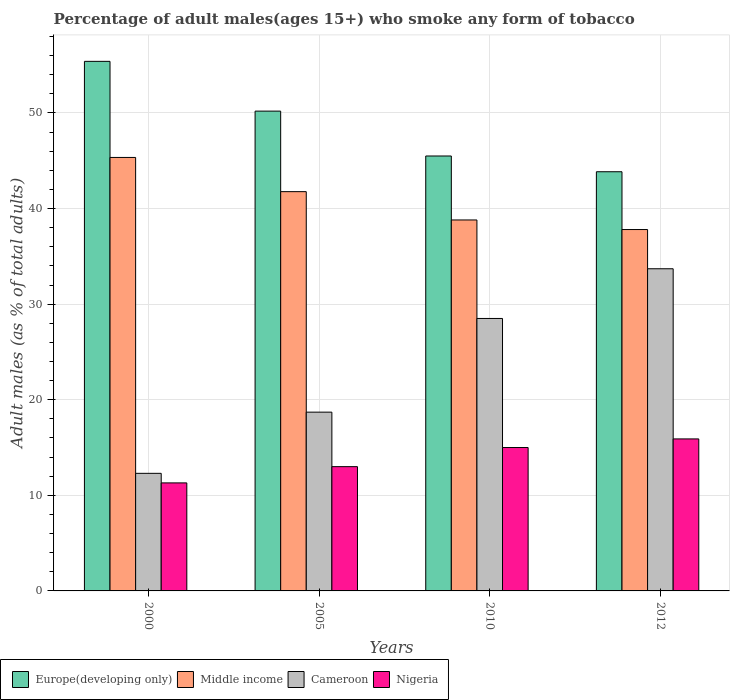How many different coloured bars are there?
Your answer should be compact. 4. What is the percentage of adult males who smoke in Europe(developing only) in 2005?
Provide a succinct answer. 50.19. Across all years, what is the maximum percentage of adult males who smoke in Cameroon?
Provide a succinct answer. 33.7. Across all years, what is the minimum percentage of adult males who smoke in Europe(developing only)?
Offer a terse response. 43.85. In which year was the percentage of adult males who smoke in Middle income minimum?
Your response must be concise. 2012. What is the total percentage of adult males who smoke in Europe(developing only) in the graph?
Your response must be concise. 194.93. What is the difference between the percentage of adult males who smoke in Middle income in 2005 and that in 2012?
Make the answer very short. 3.96. What is the difference between the percentage of adult males who smoke in Europe(developing only) in 2000 and the percentage of adult males who smoke in Cameroon in 2010?
Your answer should be compact. 26.9. What is the average percentage of adult males who smoke in Middle income per year?
Keep it short and to the point. 40.93. In how many years, is the percentage of adult males who smoke in Cameroon greater than 24 %?
Offer a very short reply. 2. What is the ratio of the percentage of adult males who smoke in Middle income in 2010 to that in 2012?
Provide a short and direct response. 1.03. Is the difference between the percentage of adult males who smoke in Nigeria in 2000 and 2005 greater than the difference between the percentage of adult males who smoke in Cameroon in 2000 and 2005?
Your answer should be very brief. Yes. What is the difference between the highest and the second highest percentage of adult males who smoke in Europe(developing only)?
Offer a terse response. 5.21. What is the difference between the highest and the lowest percentage of adult males who smoke in Europe(developing only)?
Make the answer very short. 11.55. Is the sum of the percentage of adult males who smoke in Middle income in 2000 and 2010 greater than the maximum percentage of adult males who smoke in Cameroon across all years?
Provide a short and direct response. Yes. What does the 1st bar from the left in 2000 represents?
Provide a short and direct response. Europe(developing only). Is it the case that in every year, the sum of the percentage of adult males who smoke in Middle income and percentage of adult males who smoke in Cameroon is greater than the percentage of adult males who smoke in Nigeria?
Keep it short and to the point. Yes. How many bars are there?
Offer a terse response. 16. Are all the bars in the graph horizontal?
Provide a short and direct response. No. How many years are there in the graph?
Provide a short and direct response. 4. What is the difference between two consecutive major ticks on the Y-axis?
Your answer should be very brief. 10. Does the graph contain any zero values?
Your answer should be compact. No. Does the graph contain grids?
Provide a succinct answer. Yes. Where does the legend appear in the graph?
Offer a very short reply. Bottom left. How many legend labels are there?
Your answer should be very brief. 4. How are the legend labels stacked?
Provide a short and direct response. Horizontal. What is the title of the graph?
Offer a very short reply. Percentage of adult males(ages 15+) who smoke any form of tobacco. Does "Bolivia" appear as one of the legend labels in the graph?
Provide a short and direct response. No. What is the label or title of the X-axis?
Provide a succinct answer. Years. What is the label or title of the Y-axis?
Your answer should be compact. Adult males (as % of total adults). What is the Adult males (as % of total adults) of Europe(developing only) in 2000?
Ensure brevity in your answer.  55.4. What is the Adult males (as % of total adults) of Middle income in 2000?
Give a very brief answer. 45.34. What is the Adult males (as % of total adults) in Nigeria in 2000?
Provide a succinct answer. 11.3. What is the Adult males (as % of total adults) in Europe(developing only) in 2005?
Your response must be concise. 50.19. What is the Adult males (as % of total adults) in Middle income in 2005?
Offer a terse response. 41.77. What is the Adult males (as % of total adults) in Europe(developing only) in 2010?
Your answer should be compact. 45.5. What is the Adult males (as % of total adults) in Middle income in 2010?
Provide a succinct answer. 38.8. What is the Adult males (as % of total adults) of Cameroon in 2010?
Keep it short and to the point. 28.5. What is the Adult males (as % of total adults) of Europe(developing only) in 2012?
Your answer should be very brief. 43.85. What is the Adult males (as % of total adults) of Middle income in 2012?
Your answer should be very brief. 37.8. What is the Adult males (as % of total adults) in Cameroon in 2012?
Your response must be concise. 33.7. What is the Adult males (as % of total adults) in Nigeria in 2012?
Ensure brevity in your answer.  15.9. Across all years, what is the maximum Adult males (as % of total adults) of Europe(developing only)?
Keep it short and to the point. 55.4. Across all years, what is the maximum Adult males (as % of total adults) in Middle income?
Give a very brief answer. 45.34. Across all years, what is the maximum Adult males (as % of total adults) of Cameroon?
Give a very brief answer. 33.7. Across all years, what is the minimum Adult males (as % of total adults) of Europe(developing only)?
Make the answer very short. 43.85. Across all years, what is the minimum Adult males (as % of total adults) of Middle income?
Make the answer very short. 37.8. Across all years, what is the minimum Adult males (as % of total adults) in Cameroon?
Offer a terse response. 12.3. What is the total Adult males (as % of total adults) in Europe(developing only) in the graph?
Make the answer very short. 194.93. What is the total Adult males (as % of total adults) in Middle income in the graph?
Make the answer very short. 163.71. What is the total Adult males (as % of total adults) in Cameroon in the graph?
Your answer should be compact. 93.2. What is the total Adult males (as % of total adults) in Nigeria in the graph?
Your response must be concise. 55.2. What is the difference between the Adult males (as % of total adults) in Europe(developing only) in 2000 and that in 2005?
Offer a very short reply. 5.21. What is the difference between the Adult males (as % of total adults) of Middle income in 2000 and that in 2005?
Make the answer very short. 3.58. What is the difference between the Adult males (as % of total adults) in Cameroon in 2000 and that in 2005?
Your response must be concise. -6.4. What is the difference between the Adult males (as % of total adults) of Nigeria in 2000 and that in 2005?
Provide a short and direct response. -1.7. What is the difference between the Adult males (as % of total adults) in Europe(developing only) in 2000 and that in 2010?
Offer a very short reply. 9.9. What is the difference between the Adult males (as % of total adults) of Middle income in 2000 and that in 2010?
Give a very brief answer. 6.54. What is the difference between the Adult males (as % of total adults) of Cameroon in 2000 and that in 2010?
Your response must be concise. -16.2. What is the difference between the Adult males (as % of total adults) in Nigeria in 2000 and that in 2010?
Your response must be concise. -3.7. What is the difference between the Adult males (as % of total adults) in Europe(developing only) in 2000 and that in 2012?
Offer a very short reply. 11.55. What is the difference between the Adult males (as % of total adults) in Middle income in 2000 and that in 2012?
Offer a terse response. 7.54. What is the difference between the Adult males (as % of total adults) of Cameroon in 2000 and that in 2012?
Your answer should be compact. -21.4. What is the difference between the Adult males (as % of total adults) in Nigeria in 2000 and that in 2012?
Your response must be concise. -4.6. What is the difference between the Adult males (as % of total adults) in Europe(developing only) in 2005 and that in 2010?
Your answer should be compact. 4.69. What is the difference between the Adult males (as % of total adults) in Middle income in 2005 and that in 2010?
Make the answer very short. 2.96. What is the difference between the Adult males (as % of total adults) in Cameroon in 2005 and that in 2010?
Your answer should be very brief. -9.8. What is the difference between the Adult males (as % of total adults) in Nigeria in 2005 and that in 2010?
Your response must be concise. -2. What is the difference between the Adult males (as % of total adults) of Europe(developing only) in 2005 and that in 2012?
Keep it short and to the point. 6.34. What is the difference between the Adult males (as % of total adults) of Middle income in 2005 and that in 2012?
Your response must be concise. 3.96. What is the difference between the Adult males (as % of total adults) of Nigeria in 2005 and that in 2012?
Offer a very short reply. -2.9. What is the difference between the Adult males (as % of total adults) of Europe(developing only) in 2010 and that in 2012?
Keep it short and to the point. 1.65. What is the difference between the Adult males (as % of total adults) in Middle income in 2010 and that in 2012?
Offer a terse response. 1. What is the difference between the Adult males (as % of total adults) in Cameroon in 2010 and that in 2012?
Your answer should be compact. -5.2. What is the difference between the Adult males (as % of total adults) in Nigeria in 2010 and that in 2012?
Give a very brief answer. -0.9. What is the difference between the Adult males (as % of total adults) of Europe(developing only) in 2000 and the Adult males (as % of total adults) of Middle income in 2005?
Keep it short and to the point. 13.63. What is the difference between the Adult males (as % of total adults) in Europe(developing only) in 2000 and the Adult males (as % of total adults) in Cameroon in 2005?
Your answer should be compact. 36.7. What is the difference between the Adult males (as % of total adults) in Europe(developing only) in 2000 and the Adult males (as % of total adults) in Nigeria in 2005?
Offer a terse response. 42.4. What is the difference between the Adult males (as % of total adults) of Middle income in 2000 and the Adult males (as % of total adults) of Cameroon in 2005?
Provide a short and direct response. 26.64. What is the difference between the Adult males (as % of total adults) in Middle income in 2000 and the Adult males (as % of total adults) in Nigeria in 2005?
Ensure brevity in your answer.  32.34. What is the difference between the Adult males (as % of total adults) in Europe(developing only) in 2000 and the Adult males (as % of total adults) in Middle income in 2010?
Ensure brevity in your answer.  16.59. What is the difference between the Adult males (as % of total adults) of Europe(developing only) in 2000 and the Adult males (as % of total adults) of Cameroon in 2010?
Your response must be concise. 26.9. What is the difference between the Adult males (as % of total adults) in Europe(developing only) in 2000 and the Adult males (as % of total adults) in Nigeria in 2010?
Your response must be concise. 40.4. What is the difference between the Adult males (as % of total adults) of Middle income in 2000 and the Adult males (as % of total adults) of Cameroon in 2010?
Your answer should be compact. 16.84. What is the difference between the Adult males (as % of total adults) in Middle income in 2000 and the Adult males (as % of total adults) in Nigeria in 2010?
Offer a terse response. 30.34. What is the difference between the Adult males (as % of total adults) of Cameroon in 2000 and the Adult males (as % of total adults) of Nigeria in 2010?
Provide a succinct answer. -2.7. What is the difference between the Adult males (as % of total adults) of Europe(developing only) in 2000 and the Adult males (as % of total adults) of Middle income in 2012?
Your answer should be compact. 17.59. What is the difference between the Adult males (as % of total adults) of Europe(developing only) in 2000 and the Adult males (as % of total adults) of Cameroon in 2012?
Ensure brevity in your answer.  21.7. What is the difference between the Adult males (as % of total adults) of Europe(developing only) in 2000 and the Adult males (as % of total adults) of Nigeria in 2012?
Offer a terse response. 39.5. What is the difference between the Adult males (as % of total adults) of Middle income in 2000 and the Adult males (as % of total adults) of Cameroon in 2012?
Ensure brevity in your answer.  11.64. What is the difference between the Adult males (as % of total adults) in Middle income in 2000 and the Adult males (as % of total adults) in Nigeria in 2012?
Ensure brevity in your answer.  29.44. What is the difference between the Adult males (as % of total adults) of Europe(developing only) in 2005 and the Adult males (as % of total adults) of Middle income in 2010?
Your response must be concise. 11.39. What is the difference between the Adult males (as % of total adults) of Europe(developing only) in 2005 and the Adult males (as % of total adults) of Cameroon in 2010?
Provide a short and direct response. 21.69. What is the difference between the Adult males (as % of total adults) of Europe(developing only) in 2005 and the Adult males (as % of total adults) of Nigeria in 2010?
Keep it short and to the point. 35.19. What is the difference between the Adult males (as % of total adults) of Middle income in 2005 and the Adult males (as % of total adults) of Cameroon in 2010?
Provide a succinct answer. 13.27. What is the difference between the Adult males (as % of total adults) in Middle income in 2005 and the Adult males (as % of total adults) in Nigeria in 2010?
Offer a terse response. 26.77. What is the difference between the Adult males (as % of total adults) in Cameroon in 2005 and the Adult males (as % of total adults) in Nigeria in 2010?
Give a very brief answer. 3.7. What is the difference between the Adult males (as % of total adults) of Europe(developing only) in 2005 and the Adult males (as % of total adults) of Middle income in 2012?
Make the answer very short. 12.39. What is the difference between the Adult males (as % of total adults) of Europe(developing only) in 2005 and the Adult males (as % of total adults) of Cameroon in 2012?
Make the answer very short. 16.49. What is the difference between the Adult males (as % of total adults) in Europe(developing only) in 2005 and the Adult males (as % of total adults) in Nigeria in 2012?
Your answer should be very brief. 34.29. What is the difference between the Adult males (as % of total adults) of Middle income in 2005 and the Adult males (as % of total adults) of Cameroon in 2012?
Give a very brief answer. 8.07. What is the difference between the Adult males (as % of total adults) in Middle income in 2005 and the Adult males (as % of total adults) in Nigeria in 2012?
Keep it short and to the point. 25.87. What is the difference between the Adult males (as % of total adults) of Cameroon in 2005 and the Adult males (as % of total adults) of Nigeria in 2012?
Offer a terse response. 2.8. What is the difference between the Adult males (as % of total adults) of Europe(developing only) in 2010 and the Adult males (as % of total adults) of Middle income in 2012?
Offer a very short reply. 7.69. What is the difference between the Adult males (as % of total adults) of Europe(developing only) in 2010 and the Adult males (as % of total adults) of Cameroon in 2012?
Your response must be concise. 11.8. What is the difference between the Adult males (as % of total adults) in Europe(developing only) in 2010 and the Adult males (as % of total adults) in Nigeria in 2012?
Keep it short and to the point. 29.6. What is the difference between the Adult males (as % of total adults) in Middle income in 2010 and the Adult males (as % of total adults) in Cameroon in 2012?
Give a very brief answer. 5.1. What is the difference between the Adult males (as % of total adults) in Middle income in 2010 and the Adult males (as % of total adults) in Nigeria in 2012?
Your response must be concise. 22.9. What is the average Adult males (as % of total adults) of Europe(developing only) per year?
Give a very brief answer. 48.73. What is the average Adult males (as % of total adults) in Middle income per year?
Offer a terse response. 40.93. What is the average Adult males (as % of total adults) of Cameroon per year?
Offer a very short reply. 23.3. What is the average Adult males (as % of total adults) of Nigeria per year?
Ensure brevity in your answer.  13.8. In the year 2000, what is the difference between the Adult males (as % of total adults) in Europe(developing only) and Adult males (as % of total adults) in Middle income?
Your answer should be very brief. 10.05. In the year 2000, what is the difference between the Adult males (as % of total adults) in Europe(developing only) and Adult males (as % of total adults) in Cameroon?
Offer a very short reply. 43.1. In the year 2000, what is the difference between the Adult males (as % of total adults) in Europe(developing only) and Adult males (as % of total adults) in Nigeria?
Offer a terse response. 44.1. In the year 2000, what is the difference between the Adult males (as % of total adults) of Middle income and Adult males (as % of total adults) of Cameroon?
Your answer should be very brief. 33.04. In the year 2000, what is the difference between the Adult males (as % of total adults) of Middle income and Adult males (as % of total adults) of Nigeria?
Your response must be concise. 34.04. In the year 2005, what is the difference between the Adult males (as % of total adults) in Europe(developing only) and Adult males (as % of total adults) in Middle income?
Offer a terse response. 8.42. In the year 2005, what is the difference between the Adult males (as % of total adults) in Europe(developing only) and Adult males (as % of total adults) in Cameroon?
Provide a succinct answer. 31.49. In the year 2005, what is the difference between the Adult males (as % of total adults) of Europe(developing only) and Adult males (as % of total adults) of Nigeria?
Your answer should be compact. 37.19. In the year 2005, what is the difference between the Adult males (as % of total adults) in Middle income and Adult males (as % of total adults) in Cameroon?
Your response must be concise. 23.07. In the year 2005, what is the difference between the Adult males (as % of total adults) of Middle income and Adult males (as % of total adults) of Nigeria?
Offer a very short reply. 28.77. In the year 2010, what is the difference between the Adult males (as % of total adults) in Europe(developing only) and Adult males (as % of total adults) in Middle income?
Offer a very short reply. 6.69. In the year 2010, what is the difference between the Adult males (as % of total adults) of Europe(developing only) and Adult males (as % of total adults) of Cameroon?
Offer a very short reply. 17. In the year 2010, what is the difference between the Adult males (as % of total adults) in Europe(developing only) and Adult males (as % of total adults) in Nigeria?
Give a very brief answer. 30.5. In the year 2010, what is the difference between the Adult males (as % of total adults) in Middle income and Adult males (as % of total adults) in Cameroon?
Your answer should be very brief. 10.3. In the year 2010, what is the difference between the Adult males (as % of total adults) in Middle income and Adult males (as % of total adults) in Nigeria?
Your answer should be very brief. 23.8. In the year 2012, what is the difference between the Adult males (as % of total adults) in Europe(developing only) and Adult males (as % of total adults) in Middle income?
Your response must be concise. 6.05. In the year 2012, what is the difference between the Adult males (as % of total adults) of Europe(developing only) and Adult males (as % of total adults) of Cameroon?
Offer a terse response. 10.15. In the year 2012, what is the difference between the Adult males (as % of total adults) in Europe(developing only) and Adult males (as % of total adults) in Nigeria?
Give a very brief answer. 27.95. In the year 2012, what is the difference between the Adult males (as % of total adults) in Middle income and Adult males (as % of total adults) in Cameroon?
Your response must be concise. 4.1. In the year 2012, what is the difference between the Adult males (as % of total adults) of Middle income and Adult males (as % of total adults) of Nigeria?
Your response must be concise. 21.9. In the year 2012, what is the difference between the Adult males (as % of total adults) in Cameroon and Adult males (as % of total adults) in Nigeria?
Your answer should be compact. 17.8. What is the ratio of the Adult males (as % of total adults) in Europe(developing only) in 2000 to that in 2005?
Keep it short and to the point. 1.1. What is the ratio of the Adult males (as % of total adults) in Middle income in 2000 to that in 2005?
Your response must be concise. 1.09. What is the ratio of the Adult males (as % of total adults) in Cameroon in 2000 to that in 2005?
Provide a succinct answer. 0.66. What is the ratio of the Adult males (as % of total adults) of Nigeria in 2000 to that in 2005?
Give a very brief answer. 0.87. What is the ratio of the Adult males (as % of total adults) of Europe(developing only) in 2000 to that in 2010?
Ensure brevity in your answer.  1.22. What is the ratio of the Adult males (as % of total adults) of Middle income in 2000 to that in 2010?
Offer a terse response. 1.17. What is the ratio of the Adult males (as % of total adults) in Cameroon in 2000 to that in 2010?
Provide a short and direct response. 0.43. What is the ratio of the Adult males (as % of total adults) in Nigeria in 2000 to that in 2010?
Offer a terse response. 0.75. What is the ratio of the Adult males (as % of total adults) in Europe(developing only) in 2000 to that in 2012?
Your answer should be very brief. 1.26. What is the ratio of the Adult males (as % of total adults) of Middle income in 2000 to that in 2012?
Give a very brief answer. 1.2. What is the ratio of the Adult males (as % of total adults) of Cameroon in 2000 to that in 2012?
Ensure brevity in your answer.  0.36. What is the ratio of the Adult males (as % of total adults) in Nigeria in 2000 to that in 2012?
Make the answer very short. 0.71. What is the ratio of the Adult males (as % of total adults) of Europe(developing only) in 2005 to that in 2010?
Ensure brevity in your answer.  1.1. What is the ratio of the Adult males (as % of total adults) in Middle income in 2005 to that in 2010?
Your answer should be very brief. 1.08. What is the ratio of the Adult males (as % of total adults) in Cameroon in 2005 to that in 2010?
Provide a short and direct response. 0.66. What is the ratio of the Adult males (as % of total adults) of Nigeria in 2005 to that in 2010?
Your response must be concise. 0.87. What is the ratio of the Adult males (as % of total adults) of Europe(developing only) in 2005 to that in 2012?
Provide a succinct answer. 1.14. What is the ratio of the Adult males (as % of total adults) in Middle income in 2005 to that in 2012?
Provide a short and direct response. 1.1. What is the ratio of the Adult males (as % of total adults) in Cameroon in 2005 to that in 2012?
Your answer should be compact. 0.55. What is the ratio of the Adult males (as % of total adults) of Nigeria in 2005 to that in 2012?
Your response must be concise. 0.82. What is the ratio of the Adult males (as % of total adults) in Europe(developing only) in 2010 to that in 2012?
Offer a terse response. 1.04. What is the ratio of the Adult males (as % of total adults) of Middle income in 2010 to that in 2012?
Provide a short and direct response. 1.03. What is the ratio of the Adult males (as % of total adults) of Cameroon in 2010 to that in 2012?
Keep it short and to the point. 0.85. What is the ratio of the Adult males (as % of total adults) in Nigeria in 2010 to that in 2012?
Give a very brief answer. 0.94. What is the difference between the highest and the second highest Adult males (as % of total adults) in Europe(developing only)?
Offer a very short reply. 5.21. What is the difference between the highest and the second highest Adult males (as % of total adults) in Middle income?
Provide a short and direct response. 3.58. What is the difference between the highest and the second highest Adult males (as % of total adults) in Cameroon?
Give a very brief answer. 5.2. What is the difference between the highest and the lowest Adult males (as % of total adults) of Europe(developing only)?
Your response must be concise. 11.55. What is the difference between the highest and the lowest Adult males (as % of total adults) of Middle income?
Give a very brief answer. 7.54. What is the difference between the highest and the lowest Adult males (as % of total adults) of Cameroon?
Keep it short and to the point. 21.4. What is the difference between the highest and the lowest Adult males (as % of total adults) of Nigeria?
Your answer should be very brief. 4.6. 